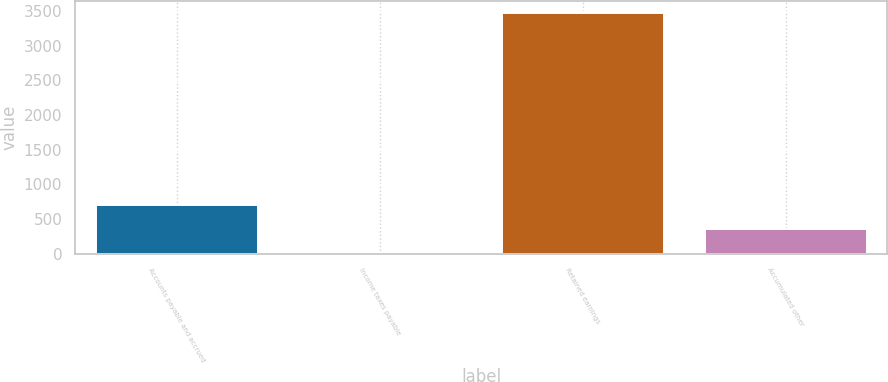<chart> <loc_0><loc_0><loc_500><loc_500><bar_chart><fcel>Accounts payable and accrued<fcel>Income taxes payable<fcel>Retained earnings<fcel>Accumulated other<nl><fcel>699.8<fcel>5<fcel>3479<fcel>352.4<nl></chart> 